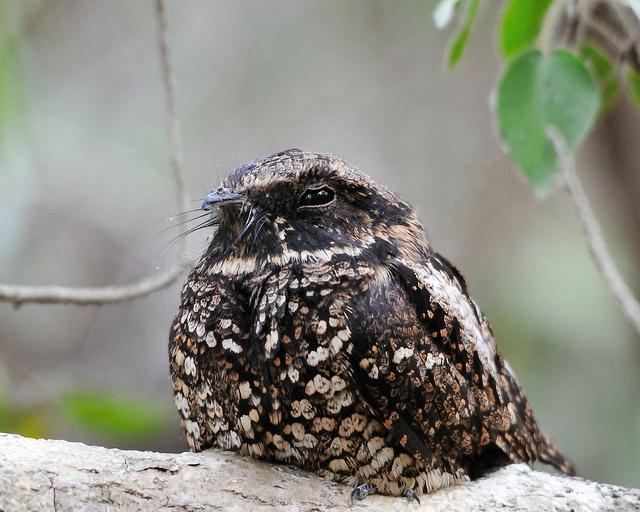What color is the bird's eye?
Concise answer only. Black. Is this bird cute?
Be succinct. Yes. What is the bird doing?
Write a very short answer. Sitting. 